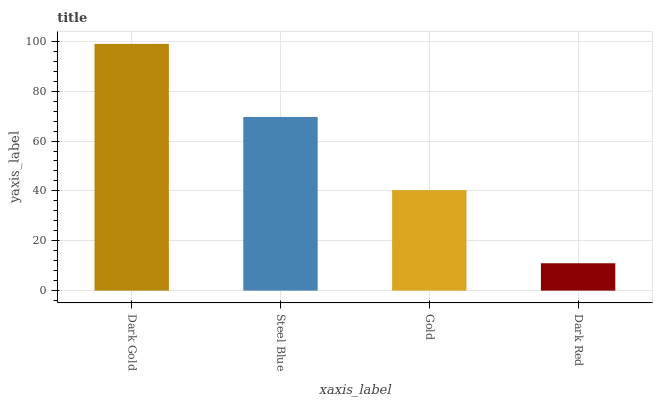Is Dark Red the minimum?
Answer yes or no. Yes. Is Dark Gold the maximum?
Answer yes or no. Yes. Is Steel Blue the minimum?
Answer yes or no. No. Is Steel Blue the maximum?
Answer yes or no. No. Is Dark Gold greater than Steel Blue?
Answer yes or no. Yes. Is Steel Blue less than Dark Gold?
Answer yes or no. Yes. Is Steel Blue greater than Dark Gold?
Answer yes or no. No. Is Dark Gold less than Steel Blue?
Answer yes or no. No. Is Steel Blue the high median?
Answer yes or no. Yes. Is Gold the low median?
Answer yes or no. Yes. Is Gold the high median?
Answer yes or no. No. Is Dark Red the low median?
Answer yes or no. No. 